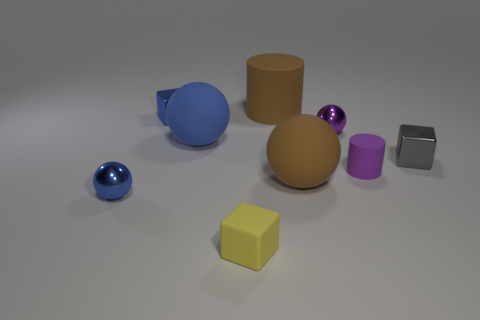The purple object that is the same material as the large brown cylinder is what shape?
Your response must be concise. Cylinder. Does the tiny yellow matte thing that is in front of the big blue thing have the same shape as the small blue thing behind the gray shiny thing?
Your response must be concise. Yes. Are there fewer tiny purple rubber cylinders that are left of the tiny gray shiny block than small blue objects to the left of the big brown cylinder?
Offer a very short reply. Yes. There is a large matte thing that is the same color as the large matte cylinder; what shape is it?
Your answer should be very brief. Sphere. What number of yellow blocks have the same size as the gray shiny block?
Provide a succinct answer. 1. Is the cube that is on the left side of the yellow thing made of the same material as the gray thing?
Your answer should be compact. Yes. Is there a tiny blue rubber cylinder?
Make the answer very short. No. What is the size of the brown sphere that is made of the same material as the yellow object?
Ensure brevity in your answer.  Large. Is there a sphere of the same color as the big cylinder?
Your answer should be very brief. Yes. Do the block that is behind the purple shiny sphere and the metallic object that is on the left side of the tiny blue metal cube have the same color?
Ensure brevity in your answer.  Yes. 